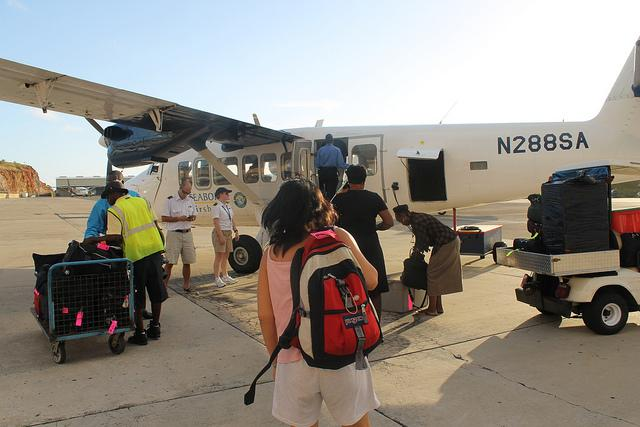Where do the people wearing white shirts work? Please explain your reasoning. airplane. The airplane staff is dressed in uniform, which is a white shirt and shorts as people are boarding the airplane. 